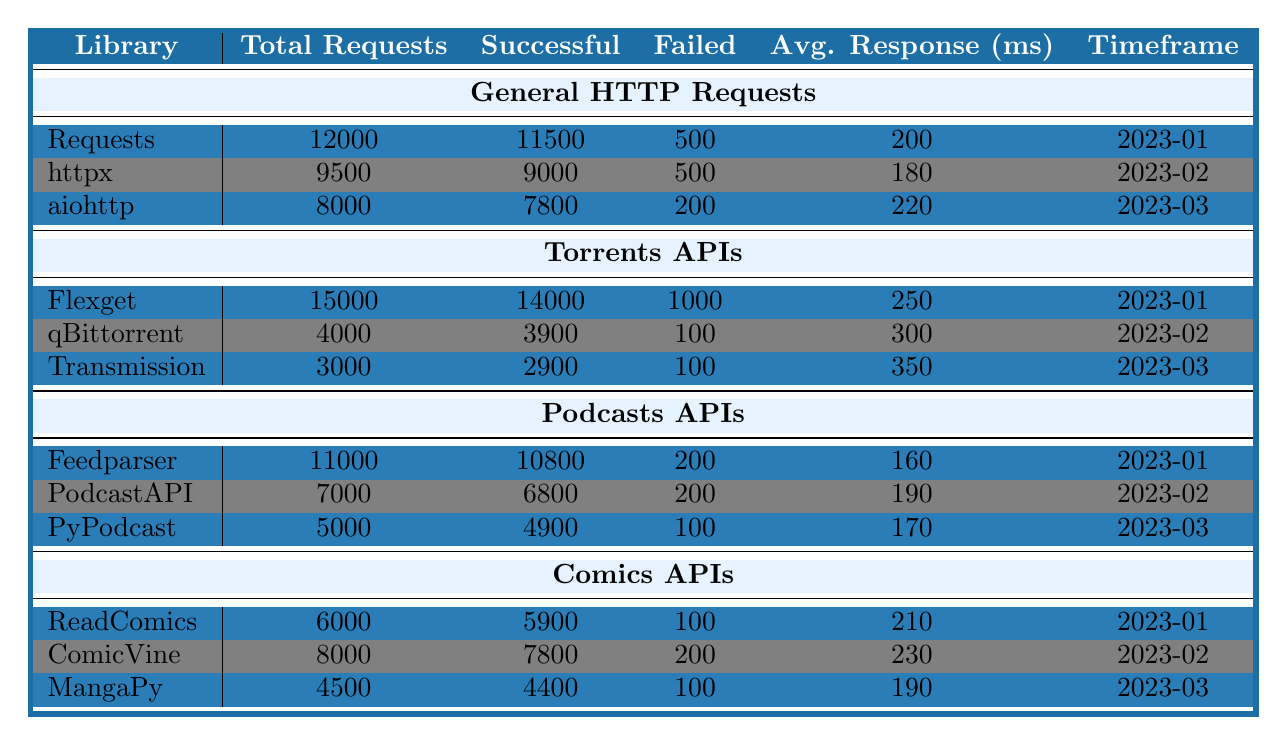What's the total number of requests for the Requests library? The total number of requests for the Requests library is listed directly in the table under "Total Requests." It shows 12,000.
Answer: 12000 How many successful requests were made with the Flexget library? The successful requests for the Flexget library are provided in the table under "Successful." This value is 14,000.
Answer: 14000 Which library had the highest average response time? To find the library with the highest average response time, compare the "Average Response (ms)" values for each library. Flexget has the highest response time of 250 ms.
Answer: Flexget What is the total number of failed requests across all Podcasts APIs? To find the total failed requests for all Podcasts APIs, add the "Failed" column values: 200 (Feedparser) + 200 (PodcastAPI) + 100 (PyPodcast) = 500.
Answer: 500 Which library had the lowest total requests in the Torrents APIs category? Looking at the "Total Requests" column in the Torrents APIs section, Transmission has the lowest total at 3,000 requests.
Answer: Transmission What is the average number of successful requests for all libraries under Comics APIs? To find the average successful requests in Comics APIs: (5900 + 7800 + 4400) / 3 = 6166.67. Rounding gives an average of approximately 6167.
Answer: 6167 Did the aiohttp library have more successful requests than failed requests? Compare the "Successful" (7,800) and "Failed" (200) values for aiohttp. Since 7,800 is greater than 200, the statement is true.
Answer: Yes Which library had the most total requests in January 2023? Review the total requests for each library in January 2023: Requests (12,000) and Flexget (15,000). Flexget had the highest requests.
Answer: Flexget What is the percentage of successful requests made by the PodcastAPI library? For PodcastAPI, successful requests are 6,800, and total requests are 7,000. The percentage is calculated as (6800 / 7000) * 100 = 97.14%.
Answer: 97.14% How do the average response times vary from the Requests library to the qBittorrent library? Compare the average response times: Requests (200 ms) and qBittorrent (300 ms). The difference is 300 - 200 = 100 ms.
Answer: 100 ms 